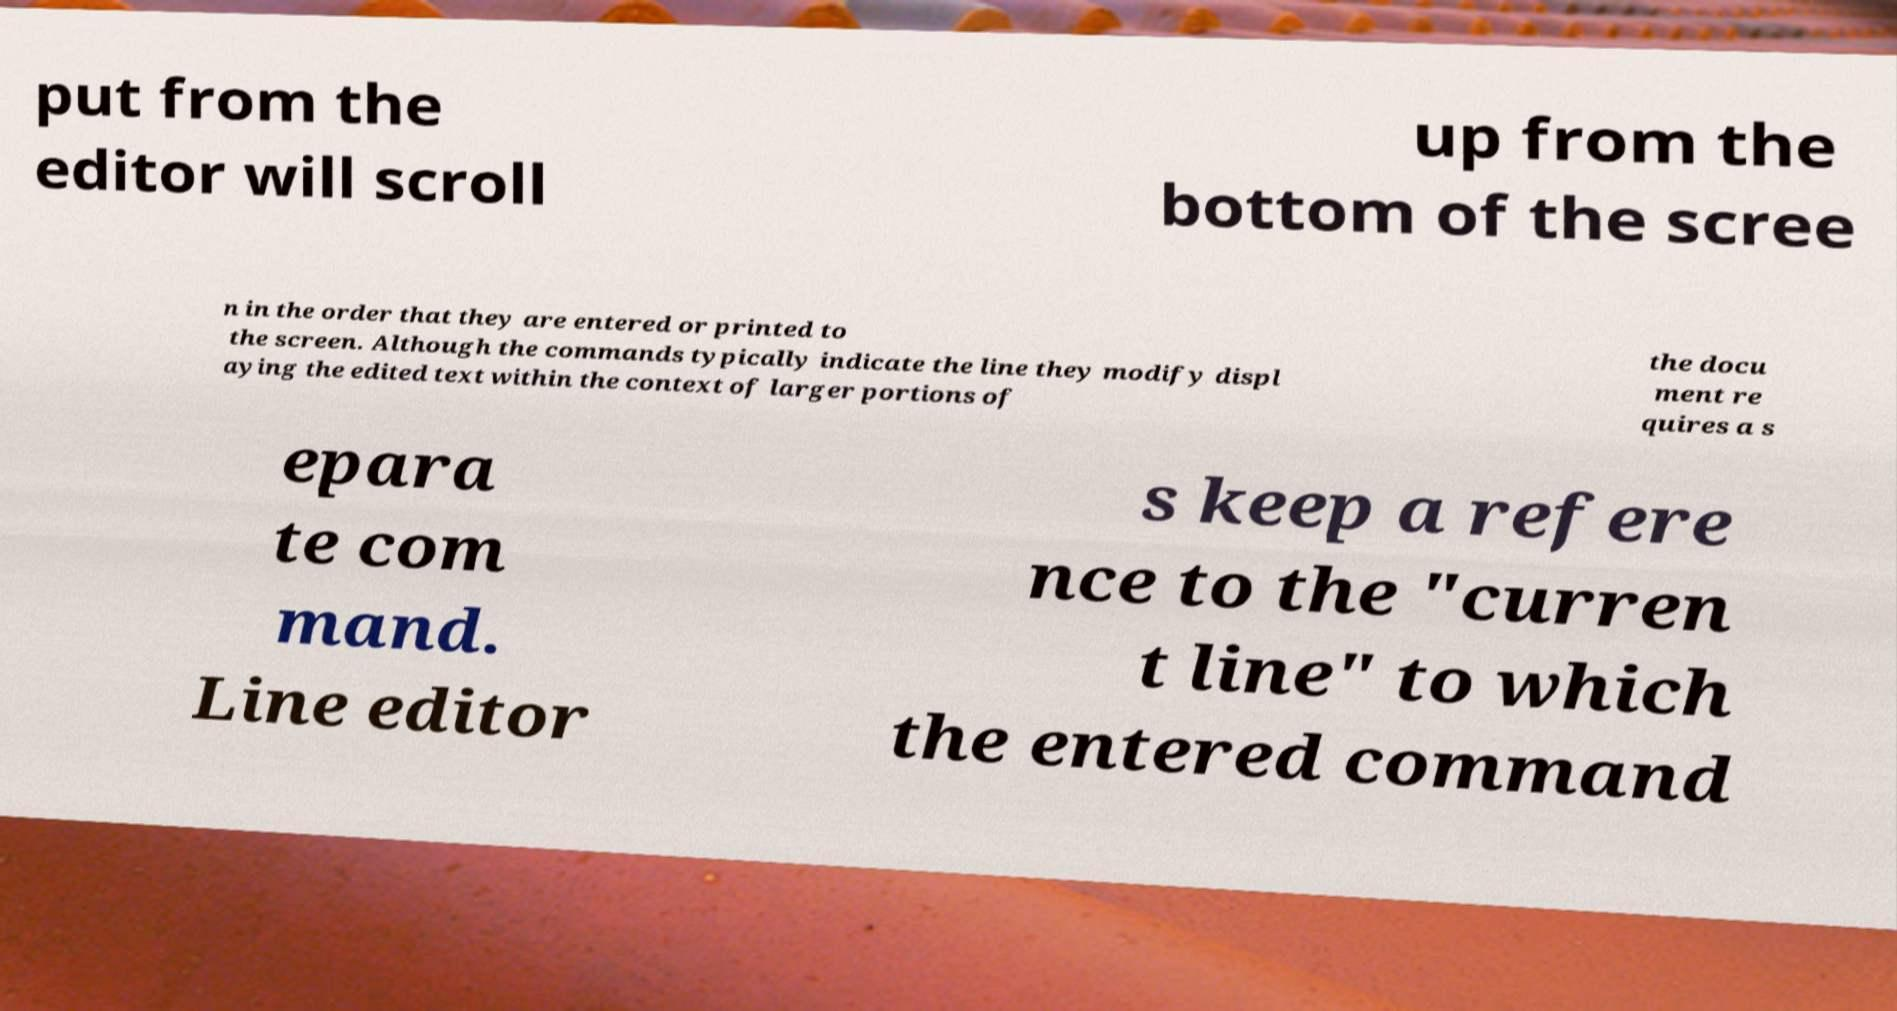Please read and relay the text visible in this image. What does it say? put from the editor will scroll up from the bottom of the scree n in the order that they are entered or printed to the screen. Although the commands typically indicate the line they modify displ aying the edited text within the context of larger portions of the docu ment re quires a s epara te com mand. Line editor s keep a refere nce to the "curren t line" to which the entered command 